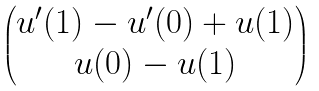<formula> <loc_0><loc_0><loc_500><loc_500>\begin{pmatrix} u ^ { \prime } ( 1 ) - u ^ { \prime } ( 0 ) + u ( 1 ) \\ u ( 0 ) - u ( 1 ) \end{pmatrix}</formula> 